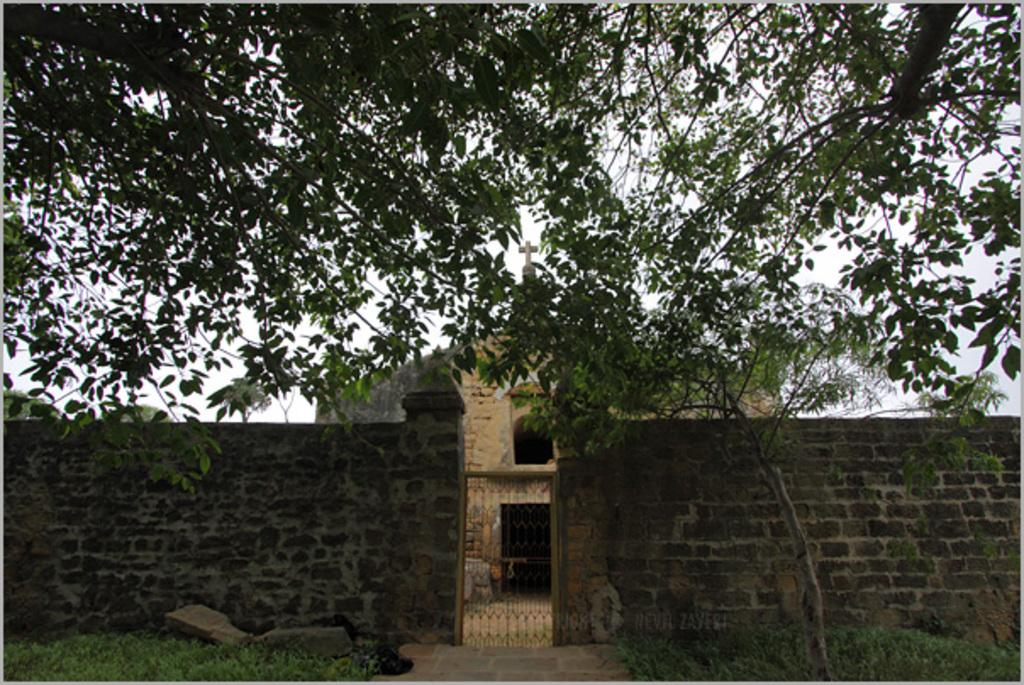What type of structure can be seen in the image? There is a wall and a gate in the image. What is the ground surface like in the image? The ground is visible in the image, and it has grass and rocks. What type of building is present in the image? There is a house in the image. What other natural elements can be seen in the image? There are trees in the image. What part of the natural environment is visible in the image? The sky is visible in the image. How many harbors can be seen in the image? There are no harbors present in the image. What type of tree is growing near the house in the image? There is no specific tree mentioned or visible in the image; only trees in general are mentioned. 